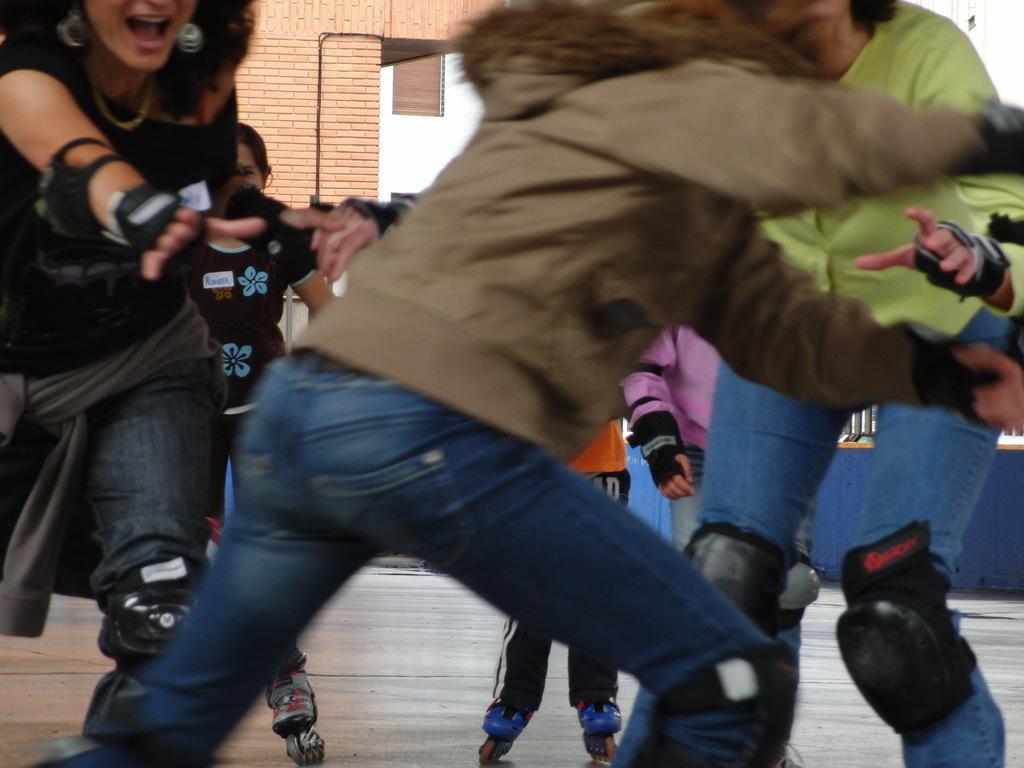In one or two sentences, can you explain what this image depicts? Int his image there are a group of people who are skating, and in the background there is building. At the bottom there is floor. 